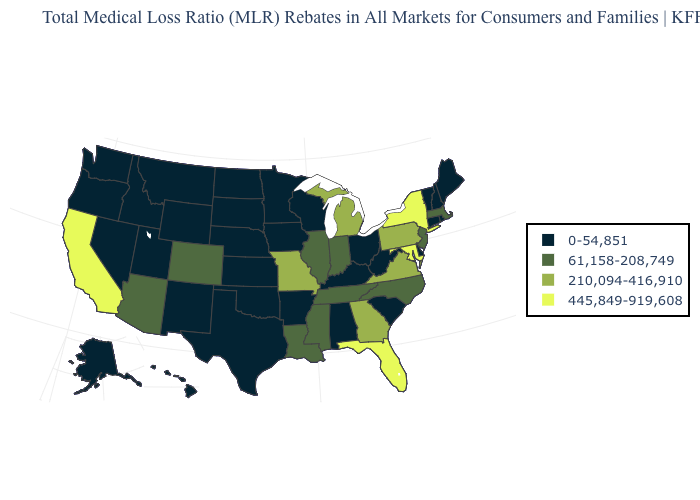What is the highest value in the USA?
Answer briefly. 445,849-919,608. Among the states that border Massachusetts , which have the highest value?
Answer briefly. New York. Which states have the highest value in the USA?
Write a very short answer. California, Florida, Maryland, New York. Which states have the lowest value in the USA?
Give a very brief answer. Alabama, Alaska, Arkansas, Connecticut, Delaware, Hawaii, Idaho, Iowa, Kansas, Kentucky, Maine, Minnesota, Montana, Nebraska, Nevada, New Hampshire, New Mexico, North Dakota, Ohio, Oklahoma, Oregon, Rhode Island, South Carolina, South Dakota, Texas, Utah, Vermont, Washington, West Virginia, Wisconsin, Wyoming. Does Massachusetts have the lowest value in the USA?
Answer briefly. No. What is the lowest value in the USA?
Answer briefly. 0-54,851. Which states have the lowest value in the USA?
Quick response, please. Alabama, Alaska, Arkansas, Connecticut, Delaware, Hawaii, Idaho, Iowa, Kansas, Kentucky, Maine, Minnesota, Montana, Nebraska, Nevada, New Hampshire, New Mexico, North Dakota, Ohio, Oklahoma, Oregon, Rhode Island, South Carolina, South Dakota, Texas, Utah, Vermont, Washington, West Virginia, Wisconsin, Wyoming. Does Mississippi have a lower value than Michigan?
Answer briefly. Yes. Name the states that have a value in the range 0-54,851?
Short answer required. Alabama, Alaska, Arkansas, Connecticut, Delaware, Hawaii, Idaho, Iowa, Kansas, Kentucky, Maine, Minnesota, Montana, Nebraska, Nevada, New Hampshire, New Mexico, North Dakota, Ohio, Oklahoma, Oregon, Rhode Island, South Carolina, South Dakota, Texas, Utah, Vermont, Washington, West Virginia, Wisconsin, Wyoming. Among the states that border Georgia , does Tennessee have the highest value?
Give a very brief answer. No. What is the lowest value in the USA?
Give a very brief answer. 0-54,851. What is the value of Hawaii?
Be succinct. 0-54,851. Does Iowa have the lowest value in the USA?
Be succinct. Yes. Does Utah have a higher value than Michigan?
Quick response, please. No. What is the value of California?
Give a very brief answer. 445,849-919,608. 